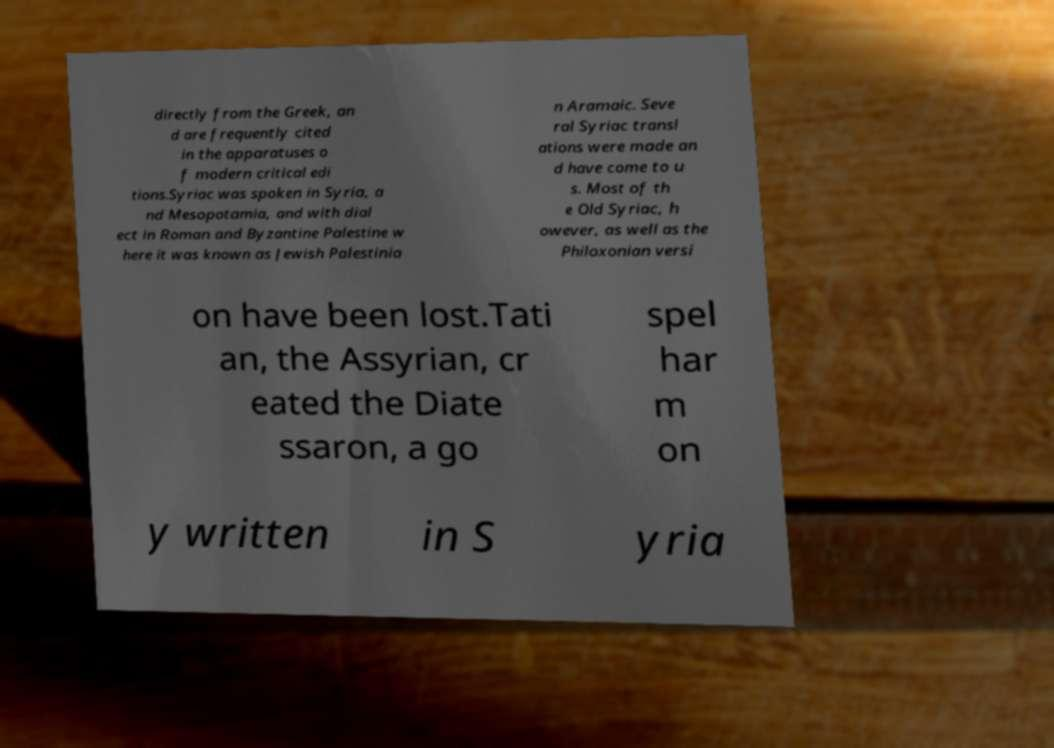I need the written content from this picture converted into text. Can you do that? directly from the Greek, an d are frequently cited in the apparatuses o f modern critical edi tions.Syriac was spoken in Syria, a nd Mesopotamia, and with dial ect in Roman and Byzantine Palestine w here it was known as Jewish Palestinia n Aramaic. Seve ral Syriac transl ations were made an d have come to u s. Most of th e Old Syriac, h owever, as well as the Philoxonian versi on have been lost.Tati an, the Assyrian, cr eated the Diate ssaron, a go spel har m on y written in S yria 